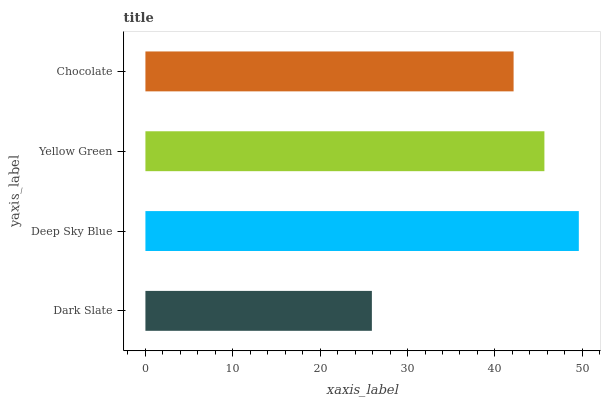Is Dark Slate the minimum?
Answer yes or no. Yes. Is Deep Sky Blue the maximum?
Answer yes or no. Yes. Is Yellow Green the minimum?
Answer yes or no. No. Is Yellow Green the maximum?
Answer yes or no. No. Is Deep Sky Blue greater than Yellow Green?
Answer yes or no. Yes. Is Yellow Green less than Deep Sky Blue?
Answer yes or no. Yes. Is Yellow Green greater than Deep Sky Blue?
Answer yes or no. No. Is Deep Sky Blue less than Yellow Green?
Answer yes or no. No. Is Yellow Green the high median?
Answer yes or no. Yes. Is Chocolate the low median?
Answer yes or no. Yes. Is Dark Slate the high median?
Answer yes or no. No. Is Dark Slate the low median?
Answer yes or no. No. 